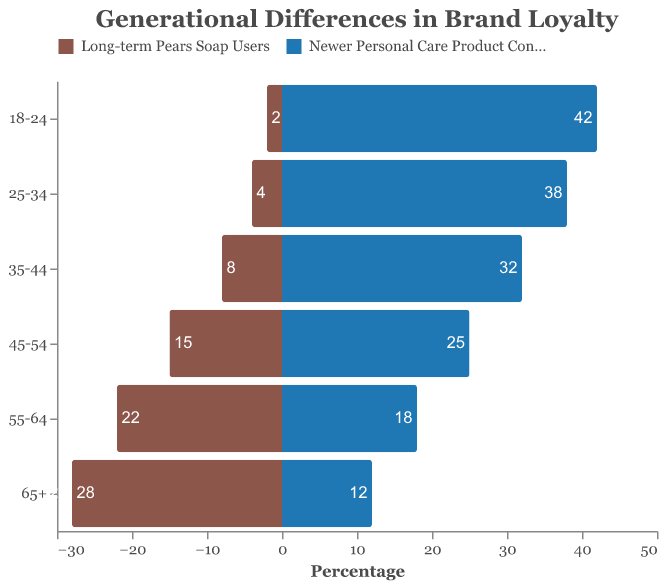What is the title of the figure? The title is displayed at the top of the figure.
Answer: Generational Differences in Brand Loyalty How many age groups are represented in the figure? Each row in the pyramid represents an age group. Counting these rows will give the number of age groups.
Answer: 6 Which age group has the highest number of long-term Pears Soap users? Identify the bar with the longest horizontal length on the side representing long-term Pears Soap users.
Answer: 65+ How does the number of newer personal care product consumers in the 18-24 age group compare to the number in the 45-54 age group? Compare the lengths of the bars on the side representing newer personal care product consumers for these two age groups.
Answer: The 18-24 age group has 17 more consumers than the 45-54 age group What is the combined total number of long-term Pears Soap users aged 55 and older? Sum the values for the 55-64 and 65+ age groups on the side representing long-term Pears Soap users.
Answer: 50 Which age group has the smallest difference between long-term Pears Soap users and newer personal care product consumers? Calculate the absolute differences for each age group and compare them.
Answer: 55-64 In which age group is the ratio of newer personal care product consumers to long-term Pears Soap users the highest? Calculate the ratio (newer personal care product consumers / long-term Pears Soap users) for each age group and compare.
Answer: 18-24 What trend can be observed in the number of long-term Pears Soap users across different age groups? Look at the pattern in the lengths of the bars on the side representing long-term Pears Soap users across the age groups.
Answer: Decreases as age decreases How many age groups have more long-term Pears Soap users than newer personal care product consumers? Count the age groups where the bar representing long-term Pears Soap users is longer than the bar for newer personal care product consumers.
Answer: 2 